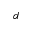Convert formula to latex. <formula><loc_0><loc_0><loc_500><loc_500>^ { d }</formula> 